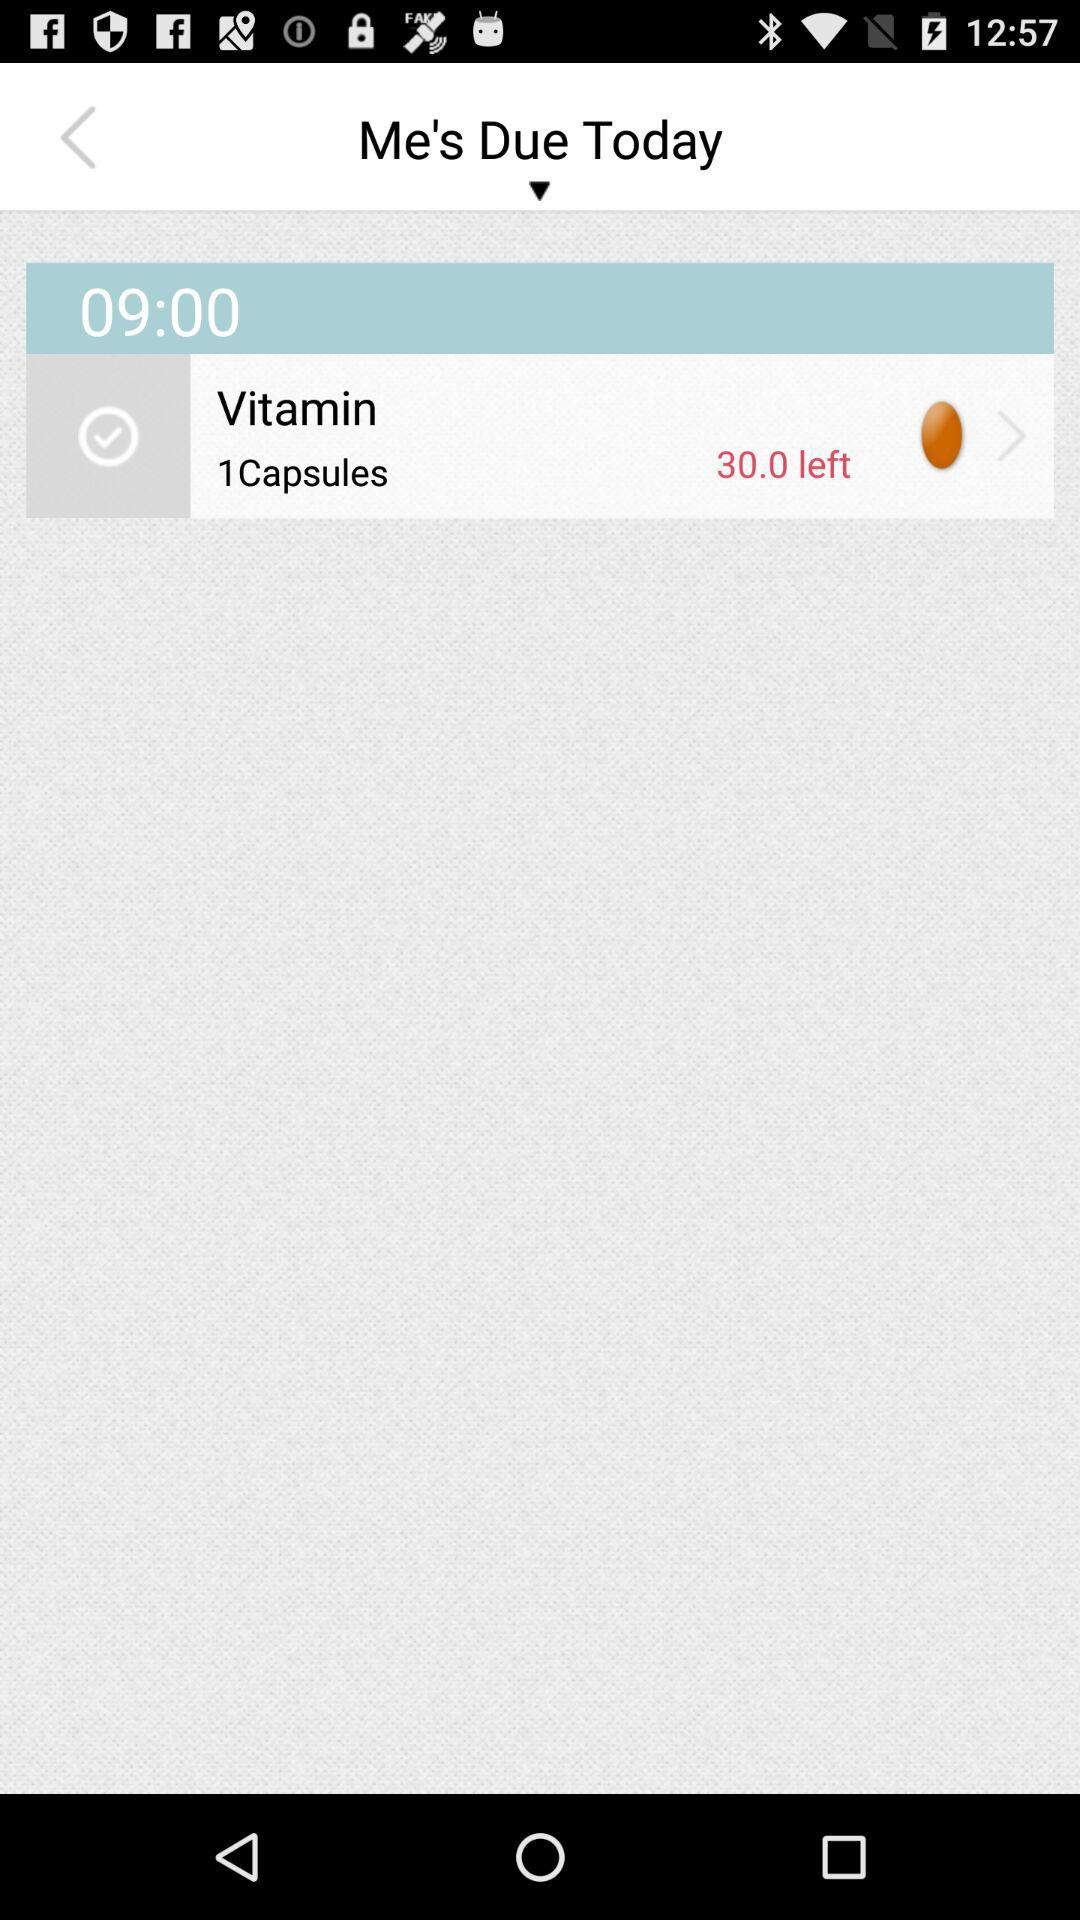At what time is the reminder set for vitamin capsules? The reminder is set for 9:00. 